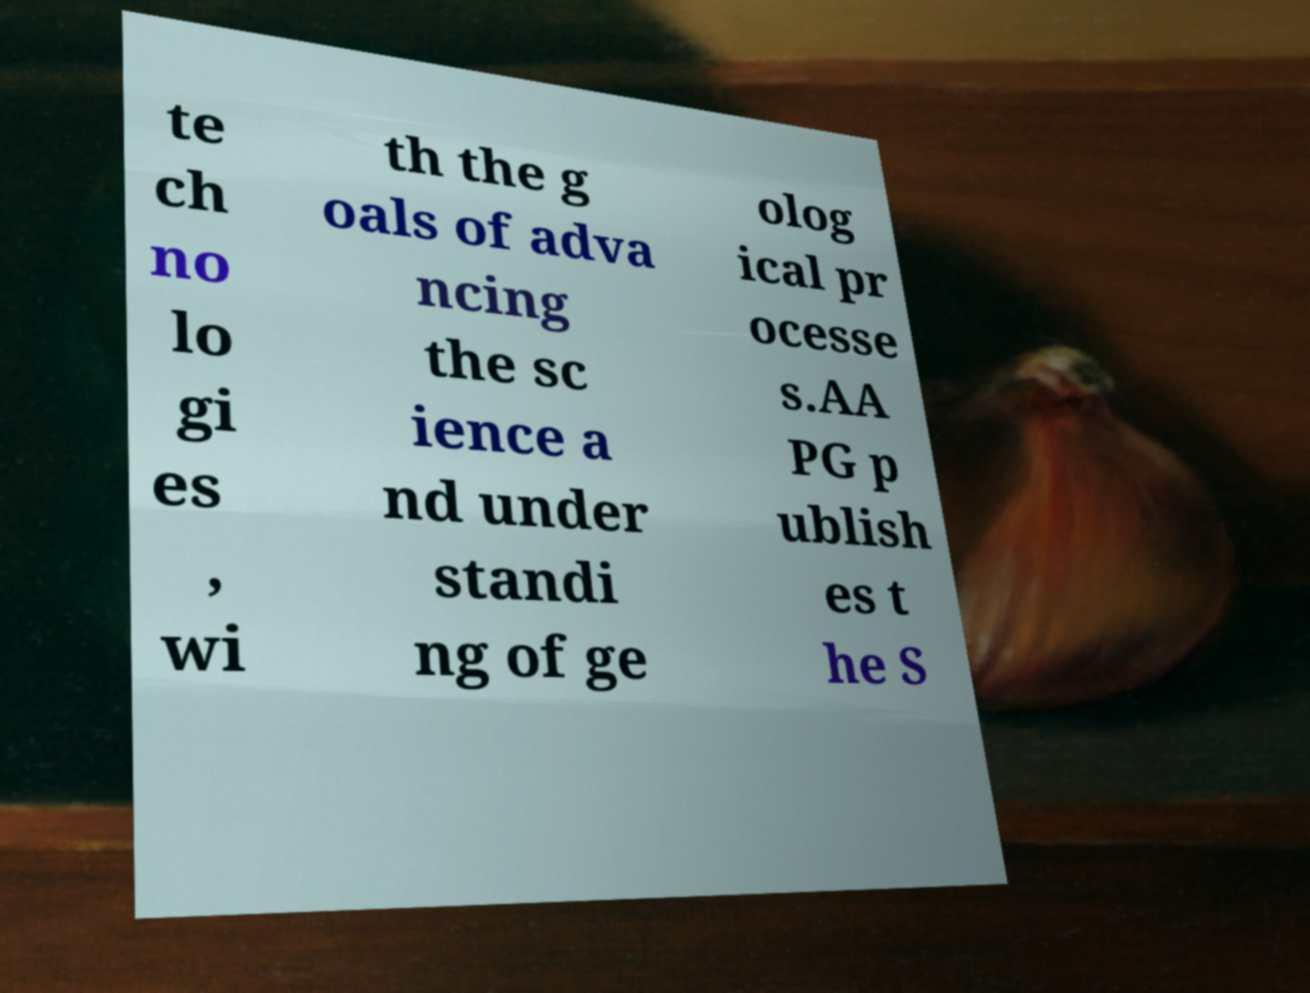Please identify and transcribe the text found in this image. te ch no lo gi es , wi th the g oals of adva ncing the sc ience a nd under standi ng of ge olog ical pr ocesse s.AA PG p ublish es t he S 